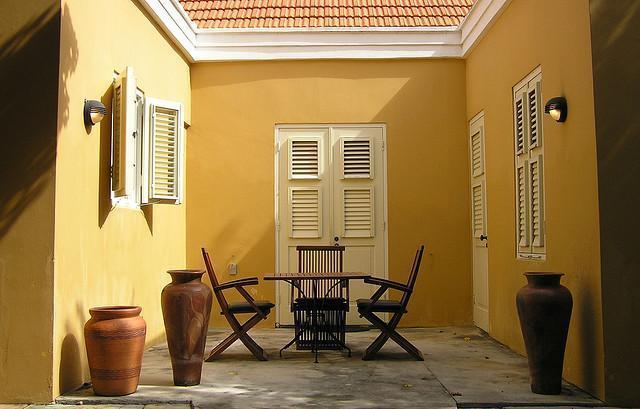How many vases are in the picture?
Give a very brief answer. 3. How many vases can you see?
Give a very brief answer. 3. How many chairs are there?
Give a very brief answer. 2. 